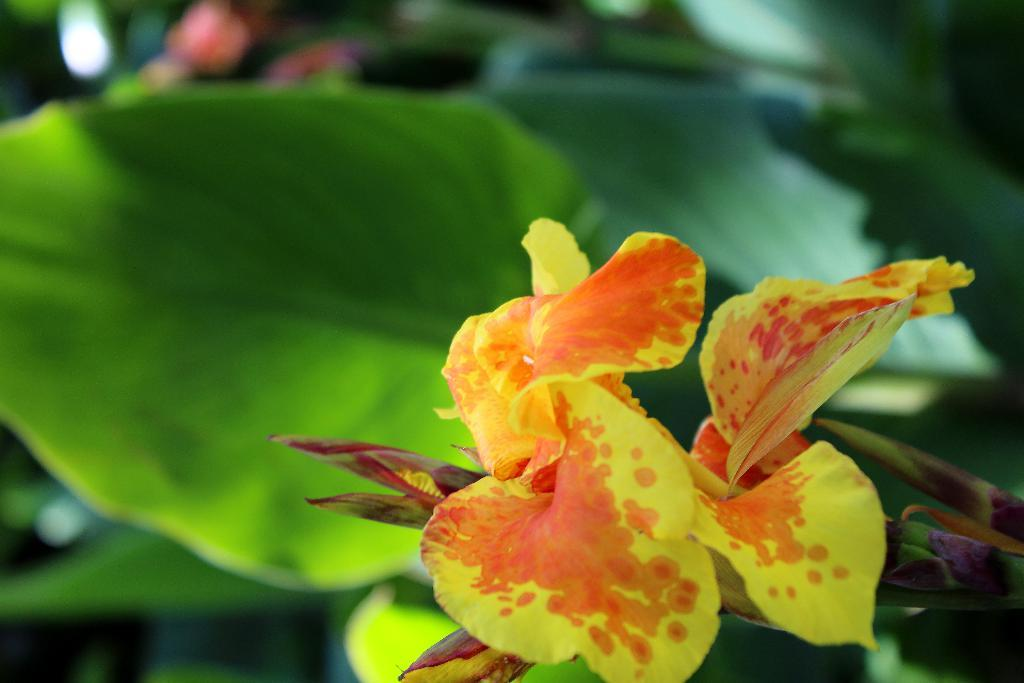What is the main subject in the front of the image? There is a flower in the front of the image. What can be seen in the background of the image? There are leaves visible in the background of the image. How many sisters are present at the seashore in the image? There is no seashore or sisters present in the image; it features a flower and leaves. 